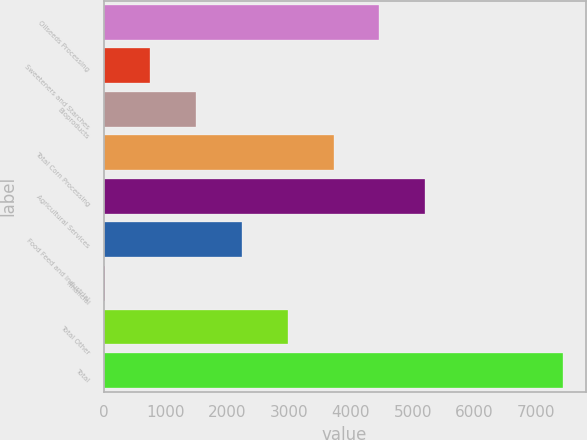Convert chart. <chart><loc_0><loc_0><loc_500><loc_500><bar_chart><fcel>Oilseeds Processing<fcel>Sweeteners and Starches<fcel>Bioproducts<fcel>Total Corn Processing<fcel>Agricultural Services<fcel>Food Feed and Industrial<fcel>Financial<fcel>Total Other<fcel>Total<nl><fcel>4460.4<fcel>758.4<fcel>1498.8<fcel>3720<fcel>5200.8<fcel>2239.2<fcel>18<fcel>2979.6<fcel>7422<nl></chart> 